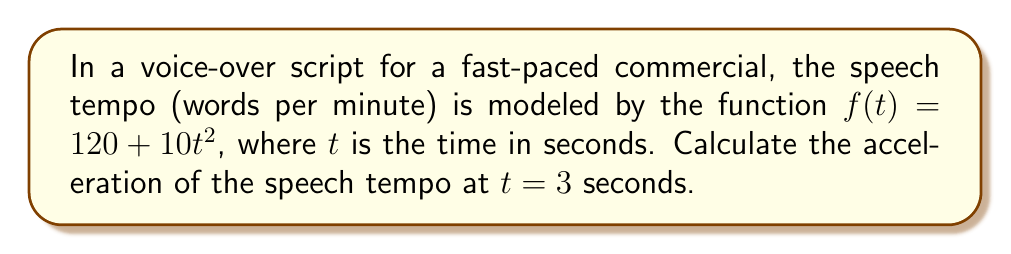Help me with this question. To find the acceleration of the speech tempo, we need to calculate the second derivative of the given function $f(t)$.

Step 1: Find the first derivative (velocity of speech tempo)
The first derivative represents the rate of change of the speech tempo:
$$f'(t) = \frac{d}{dt}(120 + 10t^2) = 20t$$

Step 2: Find the second derivative (acceleration of speech tempo)
The second derivative represents the rate of change of the velocity, which is the acceleration:
$$f''(t) = \frac{d}{dt}(20t) = 20$$

Step 3: Evaluate the acceleration at $t = 3$ seconds
Since the second derivative is a constant (20), the acceleration is the same at all times. Therefore, at $t = 3$ seconds:
$$f''(3) = 20$$

The units for this acceleration would be words per minute per second squared (words/min/s²).
Answer: 20 words/min/s² 